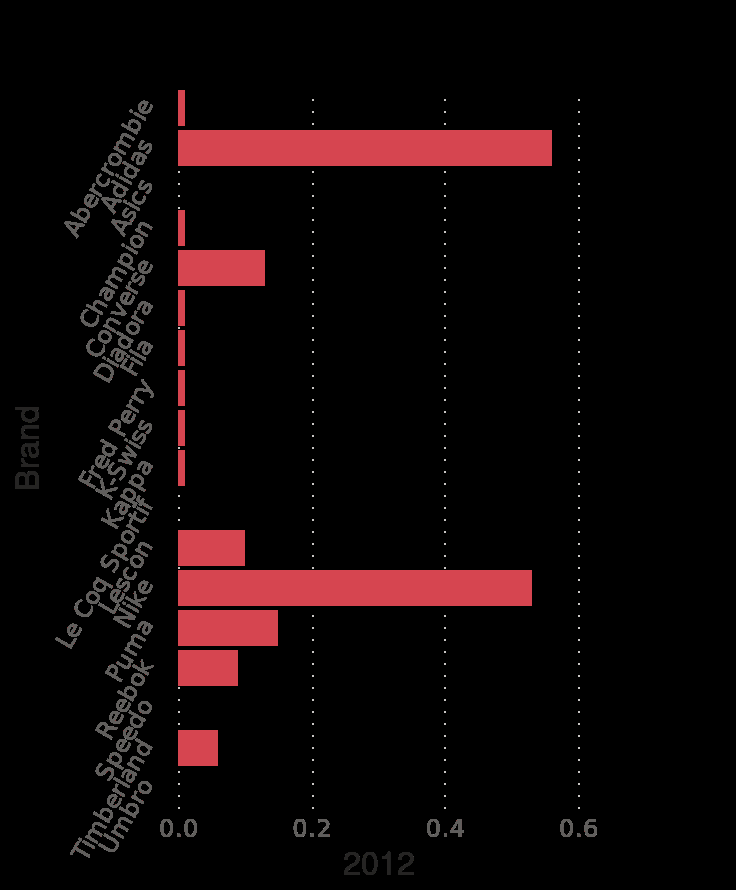<image>
What is the category scale used for on the y-axis? The category scale used on the y-axis is the brand scale, with Abercrombie on one end and another brand on the other. please summary the statistics and relations of the chart Adidas and Nike have the greatest penetration in Turkey. They have a significantly greater share than the other brands shown. A selection of other well known brands have smaller levels. Some well known brands appear to have no uptake at all. With the exception of Adidas and Nike all the other brands fall in the category of <0.2. Which brands have the greatest penetration in Turkey?  Adidas and Nike have the greatest penetration in Turkey. 